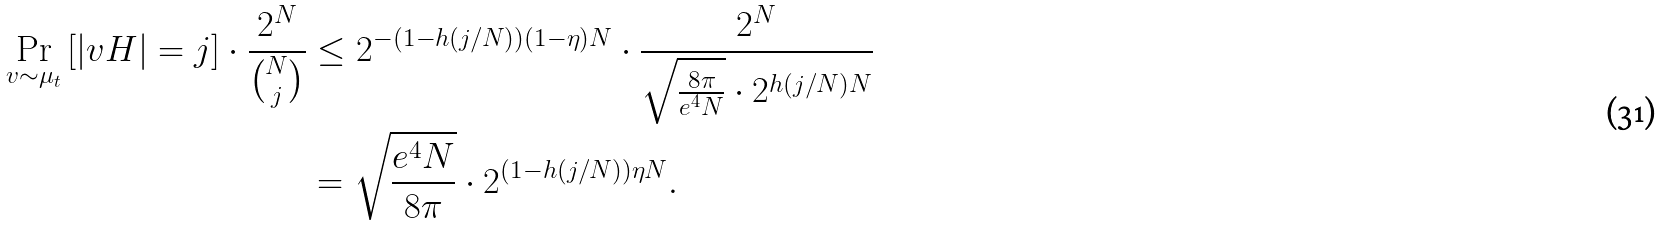<formula> <loc_0><loc_0><loc_500><loc_500>\Pr _ { v \sim \mu _ { t } } \left [ | v H | = j \right ] \cdot \frac { 2 ^ { N } } { \binom { N } { j } } & \leq 2 ^ { - ( 1 - h ( j / N ) ) ( 1 - \eta ) N } \cdot \frac { 2 ^ { N } } { \sqrt { \frac { 8 \pi } { e ^ { 4 } N } } \cdot 2 ^ { h ( j / N ) N } } \\ & = \sqrt { \frac { e ^ { 4 } N } { 8 \pi } } \cdot 2 ^ { ( 1 - h ( j / N ) ) \eta N } .</formula> 